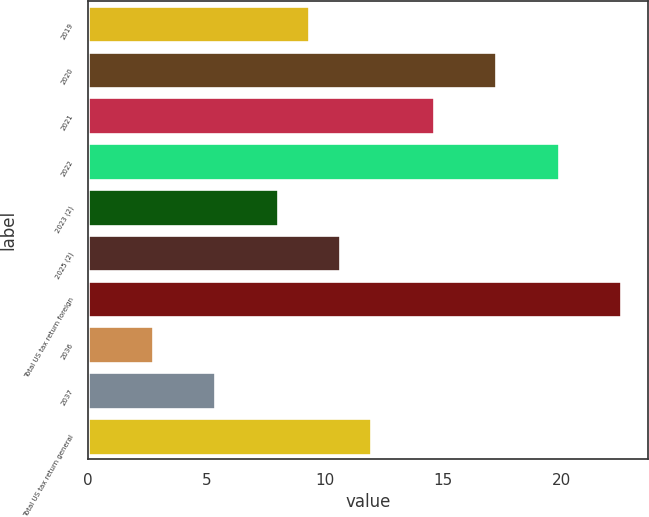Convert chart to OTSL. <chart><loc_0><loc_0><loc_500><loc_500><bar_chart><fcel>2019<fcel>2020<fcel>2021<fcel>2022<fcel>2023 (2)<fcel>2025 (2)<fcel>Total US tax return foreign<fcel>2036<fcel>2037<fcel>Total US tax return general<nl><fcel>9.34<fcel>17.26<fcel>14.62<fcel>19.9<fcel>8.02<fcel>10.66<fcel>22.54<fcel>2.74<fcel>5.38<fcel>11.98<nl></chart> 